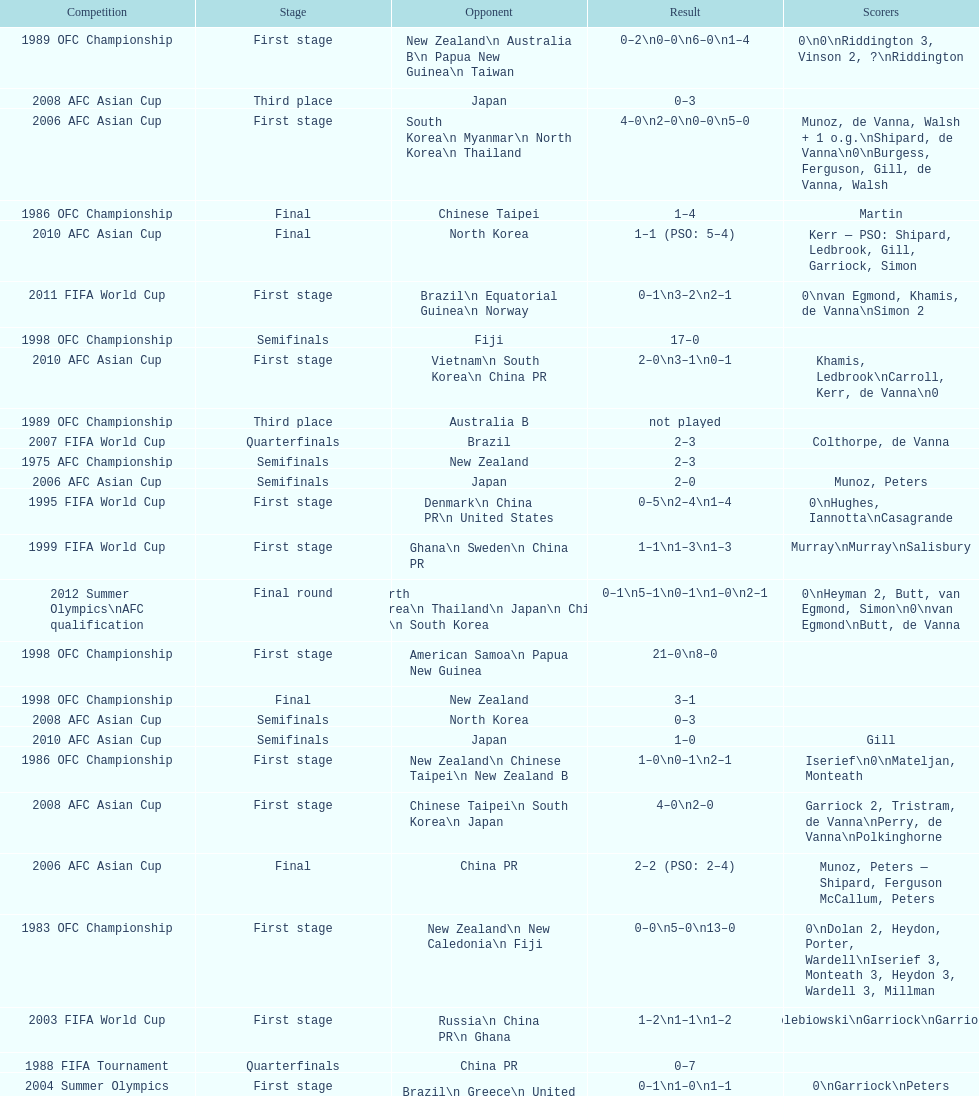Who was the last opponent this team faced in the 2010 afc asian cup? North Korea. 